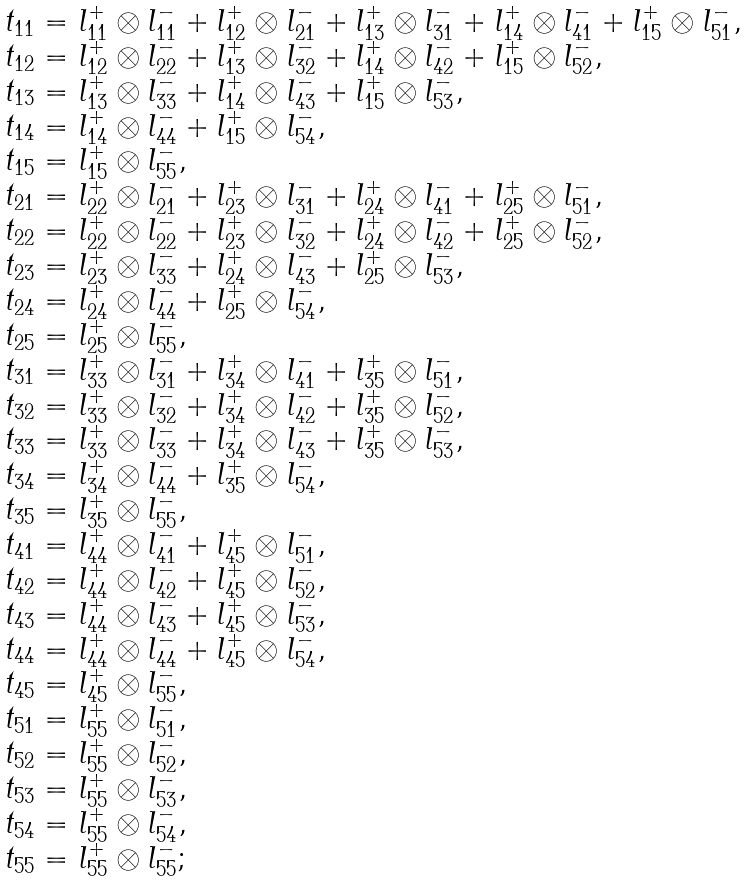Convert formula to latex. <formula><loc_0><loc_0><loc_500><loc_500>\begin{array} { l } t _ { 1 1 } = l _ { 1 1 } ^ { + } \otimes l _ { 1 1 } ^ { - } + l _ { 1 2 } ^ { + } \otimes l _ { 2 1 } ^ { - } + l _ { 1 3 } ^ { + } \otimes l _ { 3 1 } ^ { - } + l _ { 1 4 } ^ { + } \otimes l _ { 4 1 } ^ { - } + l _ { 1 5 } ^ { + } \otimes l _ { 5 1 } ^ { - } , \\ t _ { 1 2 } = l _ { 1 2 } ^ { + } \otimes l _ { 2 2 } ^ { - } + l _ { 1 3 } ^ { + } \otimes l _ { 3 2 } ^ { - } + l _ { 1 4 } ^ { + } \otimes l _ { 4 2 } ^ { - } + l _ { 1 5 } ^ { + } \otimes l _ { 5 2 } ^ { - } , \\ t _ { 1 3 } = l _ { 1 3 } ^ { + } \otimes l _ { 3 3 } ^ { - } + l _ { 1 4 } ^ { + } \otimes l _ { 4 3 } ^ { - } + l _ { 1 5 } ^ { + } \otimes l _ { 5 3 } ^ { - } , \\ t _ { 1 4 } = l _ { 1 4 } ^ { + } \otimes l _ { 4 4 } ^ { - } + l _ { 1 5 } ^ { + } \otimes l _ { 5 4 } ^ { - } , \\ t _ { 1 5 } = l _ { 1 5 } ^ { + } \otimes l _ { 5 5 } ^ { - } , \\ t _ { 2 1 } = l _ { 2 2 } ^ { + } \otimes l _ { 2 1 } ^ { - } + l _ { 2 3 } ^ { + } \otimes l _ { 3 1 } ^ { - } + l _ { 2 4 } ^ { + } \otimes l _ { 4 1 } ^ { - } + l _ { 2 5 } ^ { + } \otimes l _ { 5 1 } ^ { - } , \\ t _ { 2 2 } = l _ { 2 2 } ^ { + } \otimes l _ { 2 2 } ^ { - } + l _ { 2 3 } ^ { + } \otimes l _ { 3 2 } ^ { - } + l _ { 2 4 } ^ { + } \otimes l _ { 4 2 } ^ { - } + l _ { 2 5 } ^ { + } \otimes l _ { 5 2 } ^ { - } , \\ t _ { 2 3 } = l _ { 2 3 } ^ { + } \otimes l _ { 3 3 } ^ { - } + l _ { 2 4 } ^ { + } \otimes l _ { 4 3 } ^ { - } + l _ { 2 5 } ^ { + } \otimes l _ { 5 3 } ^ { - } , \\ t _ { 2 4 } = l _ { 2 4 } ^ { + } \otimes l _ { 4 4 } ^ { - } + l _ { 2 5 } ^ { + } \otimes l _ { 5 4 } ^ { - } , \\ t _ { 2 5 } = l _ { 2 5 } ^ { + } \otimes l _ { 5 5 } ^ { - } , \\ t _ { 3 1 } = l _ { 3 3 } ^ { + } \otimes l _ { 3 1 } ^ { - } + l _ { 3 4 } ^ { + } \otimes l _ { 4 1 } ^ { - } + l _ { 3 5 } ^ { + } \otimes l _ { 5 1 } ^ { - } , \\ t _ { 3 2 } = l _ { 3 3 } ^ { + } \otimes l _ { 3 2 } ^ { - } + l _ { 3 4 } ^ { + } \otimes l _ { 4 2 } ^ { - } + l _ { 3 5 } ^ { + } \otimes l _ { 5 2 } ^ { - } , \\ t _ { 3 3 } = l _ { 3 3 } ^ { + } \otimes l _ { 3 3 } ^ { - } + l _ { 3 4 } ^ { + } \otimes l _ { 4 3 } ^ { - } + l _ { 3 5 } ^ { + } \otimes l _ { 5 3 } ^ { - } , \\ t _ { 3 4 } = l _ { 3 4 } ^ { + } \otimes l _ { 4 4 } ^ { - } + l _ { 3 5 } ^ { + } \otimes l _ { 5 4 } ^ { - } , \\ t _ { 3 5 } = l _ { 3 5 } ^ { + } \otimes l _ { 5 5 } ^ { - } , \\ t _ { 4 1 } = l _ { 4 4 } ^ { + } \otimes l _ { 4 1 } ^ { - } + l _ { 4 5 } ^ { + } \otimes l _ { 5 1 } ^ { - } , \\ t _ { 4 2 } = l _ { 4 4 } ^ { + } \otimes l _ { 4 2 } ^ { - } + l _ { 4 5 } ^ { + } \otimes l _ { 5 2 } ^ { - } , \\ t _ { 4 3 } = l _ { 4 4 } ^ { + } \otimes l _ { 4 3 } ^ { - } + l _ { 4 5 } ^ { + } \otimes l _ { 5 3 } ^ { - } , \\ t _ { 4 4 } = l _ { 4 4 } ^ { + } \otimes l _ { 4 4 } ^ { - } + l _ { 4 5 } ^ { + } \otimes l _ { 5 4 } ^ { - } , \\ t _ { 4 5 } = l _ { 4 5 } ^ { + } \otimes l _ { 5 5 } ^ { - } , \\ t _ { 5 1 } = l _ { 5 5 } ^ { + } \otimes l _ { 5 1 } ^ { - } , \\ t _ { 5 2 } = l _ { 5 5 } ^ { + } \otimes l _ { 5 2 } ^ { - } , \\ t _ { 5 3 } = l _ { 5 5 } ^ { + } \otimes l _ { 5 3 } ^ { - } , \\ t _ { 5 4 } = l _ { 5 5 } ^ { + } \otimes l _ { 5 4 } ^ { - } , \\ t _ { 5 5 } = l _ { 5 5 } ^ { + } \otimes l _ { 5 5 } ^ { - } ; \end{array}</formula> 